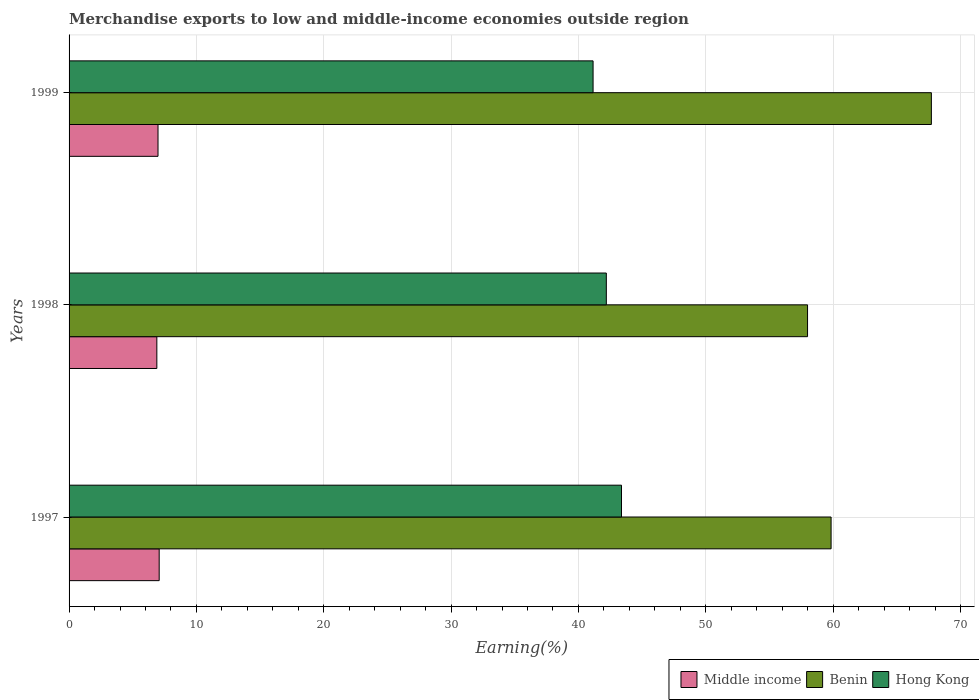How many groups of bars are there?
Offer a terse response. 3. Are the number of bars per tick equal to the number of legend labels?
Your response must be concise. Yes. How many bars are there on the 1st tick from the top?
Your answer should be very brief. 3. How many bars are there on the 2nd tick from the bottom?
Your response must be concise. 3. What is the label of the 1st group of bars from the top?
Ensure brevity in your answer.  1999. In how many cases, is the number of bars for a given year not equal to the number of legend labels?
Keep it short and to the point. 0. What is the percentage of amount earned from merchandise exports in Benin in 1998?
Offer a very short reply. 57.99. Across all years, what is the maximum percentage of amount earned from merchandise exports in Benin?
Your answer should be very brief. 67.72. Across all years, what is the minimum percentage of amount earned from merchandise exports in Benin?
Give a very brief answer. 57.99. In which year was the percentage of amount earned from merchandise exports in Benin minimum?
Keep it short and to the point. 1998. What is the total percentage of amount earned from merchandise exports in Middle income in the graph?
Ensure brevity in your answer.  20.95. What is the difference between the percentage of amount earned from merchandise exports in Hong Kong in 1997 and that in 1998?
Your answer should be compact. 1.19. What is the difference between the percentage of amount earned from merchandise exports in Hong Kong in 1998 and the percentage of amount earned from merchandise exports in Middle income in 1999?
Your answer should be compact. 35.21. What is the average percentage of amount earned from merchandise exports in Middle income per year?
Make the answer very short. 6.98. In the year 1997, what is the difference between the percentage of amount earned from merchandise exports in Benin and percentage of amount earned from merchandise exports in Middle income?
Offer a very short reply. 52.76. In how many years, is the percentage of amount earned from merchandise exports in Middle income greater than 16 %?
Ensure brevity in your answer.  0. What is the ratio of the percentage of amount earned from merchandise exports in Hong Kong in 1998 to that in 1999?
Provide a short and direct response. 1.03. Is the percentage of amount earned from merchandise exports in Benin in 1997 less than that in 1999?
Provide a short and direct response. Yes. What is the difference between the highest and the second highest percentage of amount earned from merchandise exports in Middle income?
Ensure brevity in your answer.  0.09. What is the difference between the highest and the lowest percentage of amount earned from merchandise exports in Middle income?
Your answer should be very brief. 0.18. What does the 3rd bar from the top in 1999 represents?
Provide a succinct answer. Middle income. Does the graph contain grids?
Offer a very short reply. Yes. What is the title of the graph?
Your answer should be compact. Merchandise exports to low and middle-income economies outside region. Does "Sudan" appear as one of the legend labels in the graph?
Make the answer very short. No. What is the label or title of the X-axis?
Provide a succinct answer. Earning(%). What is the label or title of the Y-axis?
Provide a succinct answer. Years. What is the Earning(%) of Middle income in 1997?
Provide a succinct answer. 7.08. What is the Earning(%) of Benin in 1997?
Make the answer very short. 59.84. What is the Earning(%) of Hong Kong in 1997?
Your response must be concise. 43.38. What is the Earning(%) of Middle income in 1998?
Make the answer very short. 6.89. What is the Earning(%) of Benin in 1998?
Your response must be concise. 57.99. What is the Earning(%) in Hong Kong in 1998?
Provide a succinct answer. 42.19. What is the Earning(%) of Middle income in 1999?
Your answer should be compact. 6.98. What is the Earning(%) in Benin in 1999?
Your answer should be very brief. 67.72. What is the Earning(%) of Hong Kong in 1999?
Your answer should be very brief. 41.15. Across all years, what is the maximum Earning(%) in Middle income?
Your answer should be very brief. 7.08. Across all years, what is the maximum Earning(%) in Benin?
Your answer should be very brief. 67.72. Across all years, what is the maximum Earning(%) of Hong Kong?
Your answer should be very brief. 43.38. Across all years, what is the minimum Earning(%) of Middle income?
Your response must be concise. 6.89. Across all years, what is the minimum Earning(%) of Benin?
Your answer should be compact. 57.99. Across all years, what is the minimum Earning(%) of Hong Kong?
Give a very brief answer. 41.15. What is the total Earning(%) of Middle income in the graph?
Offer a terse response. 20.95. What is the total Earning(%) of Benin in the graph?
Ensure brevity in your answer.  185.55. What is the total Earning(%) of Hong Kong in the graph?
Your answer should be very brief. 126.72. What is the difference between the Earning(%) in Middle income in 1997 and that in 1998?
Provide a short and direct response. 0.18. What is the difference between the Earning(%) of Benin in 1997 and that in 1998?
Your answer should be compact. 1.85. What is the difference between the Earning(%) in Hong Kong in 1997 and that in 1998?
Provide a short and direct response. 1.19. What is the difference between the Earning(%) in Middle income in 1997 and that in 1999?
Your answer should be compact. 0.09. What is the difference between the Earning(%) in Benin in 1997 and that in 1999?
Offer a very short reply. -7.88. What is the difference between the Earning(%) of Hong Kong in 1997 and that in 1999?
Make the answer very short. 2.23. What is the difference between the Earning(%) of Middle income in 1998 and that in 1999?
Your response must be concise. -0.09. What is the difference between the Earning(%) in Benin in 1998 and that in 1999?
Provide a succinct answer. -9.72. What is the difference between the Earning(%) of Hong Kong in 1998 and that in 1999?
Your answer should be very brief. 1.04. What is the difference between the Earning(%) of Middle income in 1997 and the Earning(%) of Benin in 1998?
Offer a terse response. -50.92. What is the difference between the Earning(%) in Middle income in 1997 and the Earning(%) in Hong Kong in 1998?
Ensure brevity in your answer.  -35.11. What is the difference between the Earning(%) in Benin in 1997 and the Earning(%) in Hong Kong in 1998?
Offer a terse response. 17.65. What is the difference between the Earning(%) of Middle income in 1997 and the Earning(%) of Benin in 1999?
Ensure brevity in your answer.  -60.64. What is the difference between the Earning(%) of Middle income in 1997 and the Earning(%) of Hong Kong in 1999?
Your response must be concise. -34.07. What is the difference between the Earning(%) in Benin in 1997 and the Earning(%) in Hong Kong in 1999?
Your answer should be very brief. 18.69. What is the difference between the Earning(%) in Middle income in 1998 and the Earning(%) in Benin in 1999?
Make the answer very short. -60.82. What is the difference between the Earning(%) of Middle income in 1998 and the Earning(%) of Hong Kong in 1999?
Provide a short and direct response. -34.26. What is the difference between the Earning(%) of Benin in 1998 and the Earning(%) of Hong Kong in 1999?
Your answer should be very brief. 16.84. What is the average Earning(%) of Middle income per year?
Make the answer very short. 6.98. What is the average Earning(%) in Benin per year?
Your answer should be compact. 61.85. What is the average Earning(%) of Hong Kong per year?
Offer a terse response. 42.24. In the year 1997, what is the difference between the Earning(%) in Middle income and Earning(%) in Benin?
Give a very brief answer. -52.76. In the year 1997, what is the difference between the Earning(%) of Middle income and Earning(%) of Hong Kong?
Offer a terse response. -36.3. In the year 1997, what is the difference between the Earning(%) in Benin and Earning(%) in Hong Kong?
Provide a short and direct response. 16.46. In the year 1998, what is the difference between the Earning(%) in Middle income and Earning(%) in Benin?
Your response must be concise. -51.1. In the year 1998, what is the difference between the Earning(%) of Middle income and Earning(%) of Hong Kong?
Ensure brevity in your answer.  -35.3. In the year 1998, what is the difference between the Earning(%) of Benin and Earning(%) of Hong Kong?
Offer a very short reply. 15.8. In the year 1999, what is the difference between the Earning(%) of Middle income and Earning(%) of Benin?
Your response must be concise. -60.73. In the year 1999, what is the difference between the Earning(%) of Middle income and Earning(%) of Hong Kong?
Provide a succinct answer. -34.17. In the year 1999, what is the difference between the Earning(%) in Benin and Earning(%) in Hong Kong?
Make the answer very short. 26.57. What is the ratio of the Earning(%) of Middle income in 1997 to that in 1998?
Provide a short and direct response. 1.03. What is the ratio of the Earning(%) of Benin in 1997 to that in 1998?
Your response must be concise. 1.03. What is the ratio of the Earning(%) in Hong Kong in 1997 to that in 1998?
Give a very brief answer. 1.03. What is the ratio of the Earning(%) of Middle income in 1997 to that in 1999?
Provide a succinct answer. 1.01. What is the ratio of the Earning(%) of Benin in 1997 to that in 1999?
Keep it short and to the point. 0.88. What is the ratio of the Earning(%) of Hong Kong in 1997 to that in 1999?
Offer a very short reply. 1.05. What is the ratio of the Earning(%) of Middle income in 1998 to that in 1999?
Give a very brief answer. 0.99. What is the ratio of the Earning(%) in Benin in 1998 to that in 1999?
Your answer should be very brief. 0.86. What is the ratio of the Earning(%) in Hong Kong in 1998 to that in 1999?
Ensure brevity in your answer.  1.03. What is the difference between the highest and the second highest Earning(%) in Middle income?
Offer a terse response. 0.09. What is the difference between the highest and the second highest Earning(%) of Benin?
Give a very brief answer. 7.88. What is the difference between the highest and the second highest Earning(%) in Hong Kong?
Give a very brief answer. 1.19. What is the difference between the highest and the lowest Earning(%) of Middle income?
Offer a very short reply. 0.18. What is the difference between the highest and the lowest Earning(%) of Benin?
Offer a very short reply. 9.72. What is the difference between the highest and the lowest Earning(%) in Hong Kong?
Ensure brevity in your answer.  2.23. 